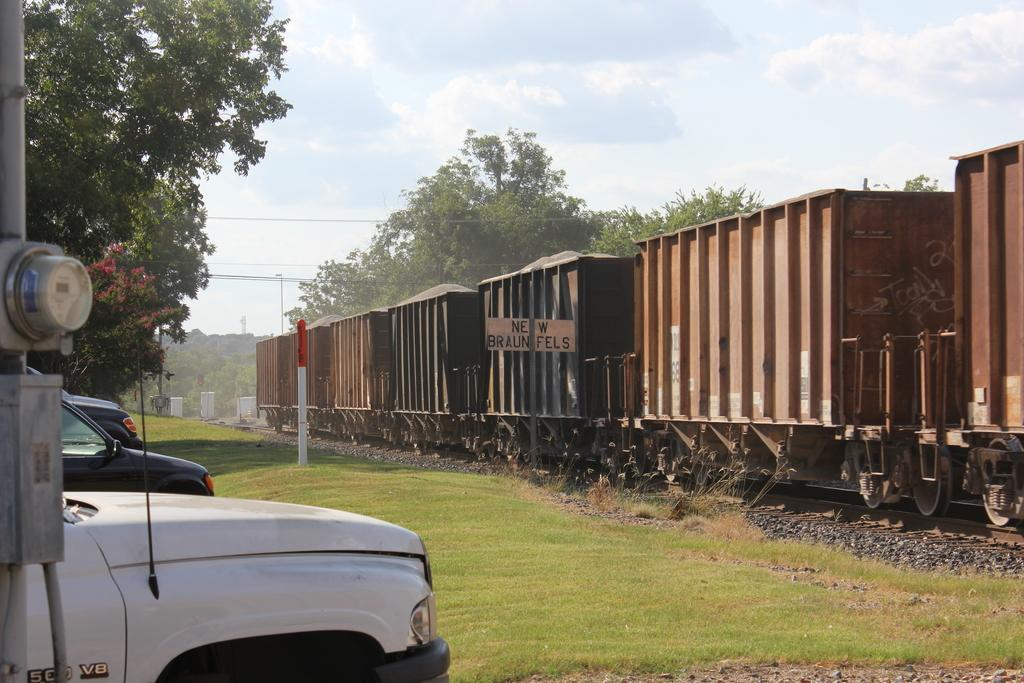What is the main subject of the image? The main subject of the image is a train on the track. What can be seen to the left of the train? There are poles, vehicles, and trees to the left of the train. What is visible in the background of the image? Trees, clouds, and the sky are visible in the background of the image. What type of ornament is hanging from the train in the image? There is no ornament hanging from the train in the image. What color are the crook's jeans in the image? There is no crook or jeans present in the image. 